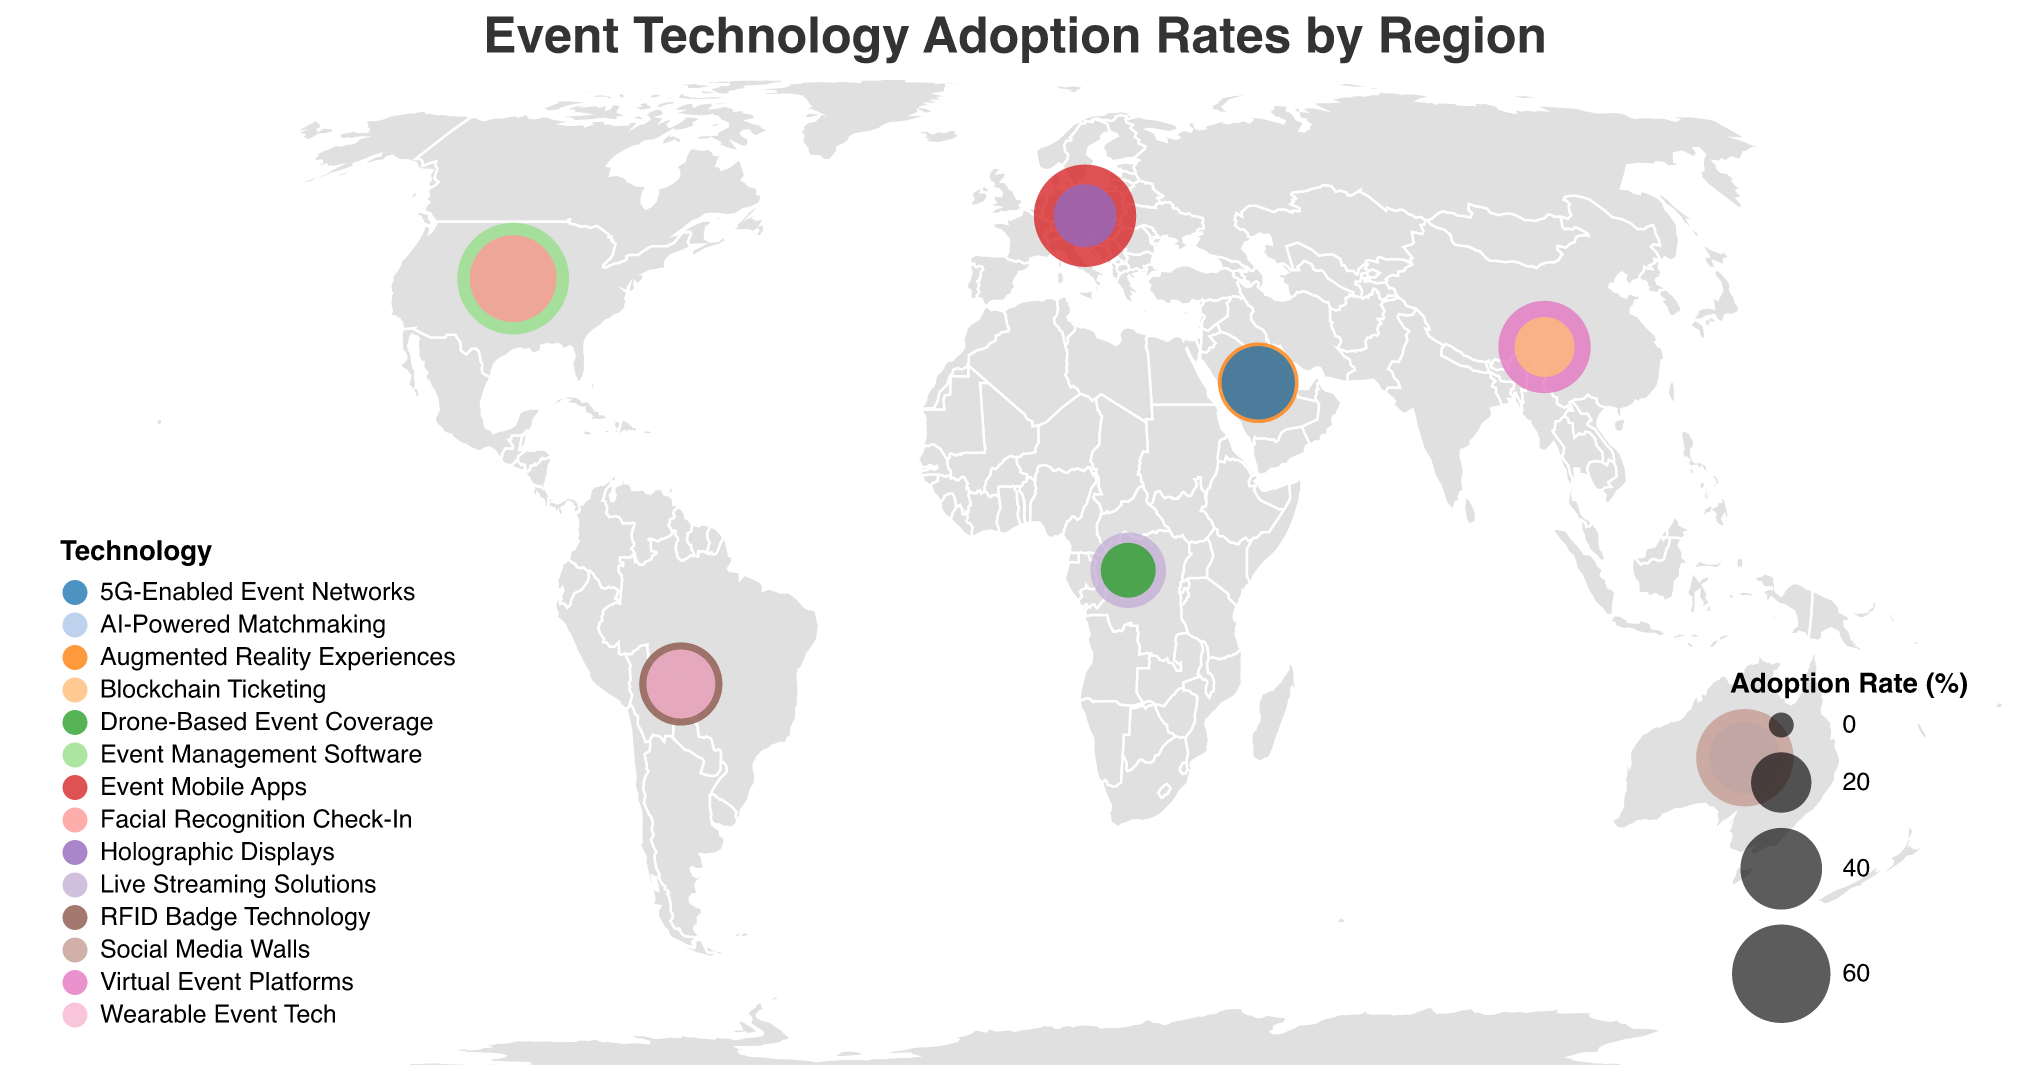What is the highest technology adoption rate in the figure? To find the highest adoption rate, look for the largest circle size in the plot. Based on the plot, "Event Management Software" in North America has the largest circle size.
Answer: 78.5% Which region has the lowest adoption rate technology? Identify the smallest circle on the plot, which represents the lowest adoption rate. The smallest circle corresponds to "Drone-Based Event Coverage" in Africa.
Answer: Africa What technology is most adopted in the Asia Pacific region? Locate the Asia Pacific region on the map and refer to the technology mentioned there. The technology with an adoption rate of 52.3% is "Virtual Event Platforms".
Answer: Virtual Event Platforms How many regions have adoption rates below 40%? Count the circles representing technologies with adoption rates under 40%. These are the technologies in the Middle East with 38.9%, Africa with 33.6%, Oceania with 29.4%, Europe with 22.1%, Asia Pacific with 19.7%, and Africa again with 15.8%.
Answer: 6 Which technology has the highest adoption rate in Europe? Locate Europe on the map and check for the technology with the highest adoption rate. "Event Mobile Apps" has a 65.2% adoption rate, which is the highest in Europe.
Answer: Event Mobile Apps Compare the adoption rates of the two technologies in North America. Which one is higher? Look at the adoption rates for "Event Management Software" (78.5%) and "Facial Recognition Check-In" (45.8%) in North America and compare them.
Answer: Event Management Software What is the difference in adoption rates between the highest and lowest technology in the dataset? Identify the highest (78.5%) and lowest (15.8%) adoption rates in the dataset and then subtract the lowest from the highest (78.5% - 15.8%).
Answer: 62.7% Which region has the second-highest adoption rate and what is the technology associated with it? Find the second-largest circle on the plot. The second-highest adoption rate is in Europe with "Event Mobile Apps" at 65.2%.
Answer: Europe, Event Mobile Apps How does the adoption rate of "5G-Enabled Event Networks" in the Middle East compare to "Social Media Walls" in Oceania? Compare the adoption rates of "5G-Enabled Event Networks" (31.5%) and "Social Media Walls" (58.6%).
Answer: Social Media Walls is higher 